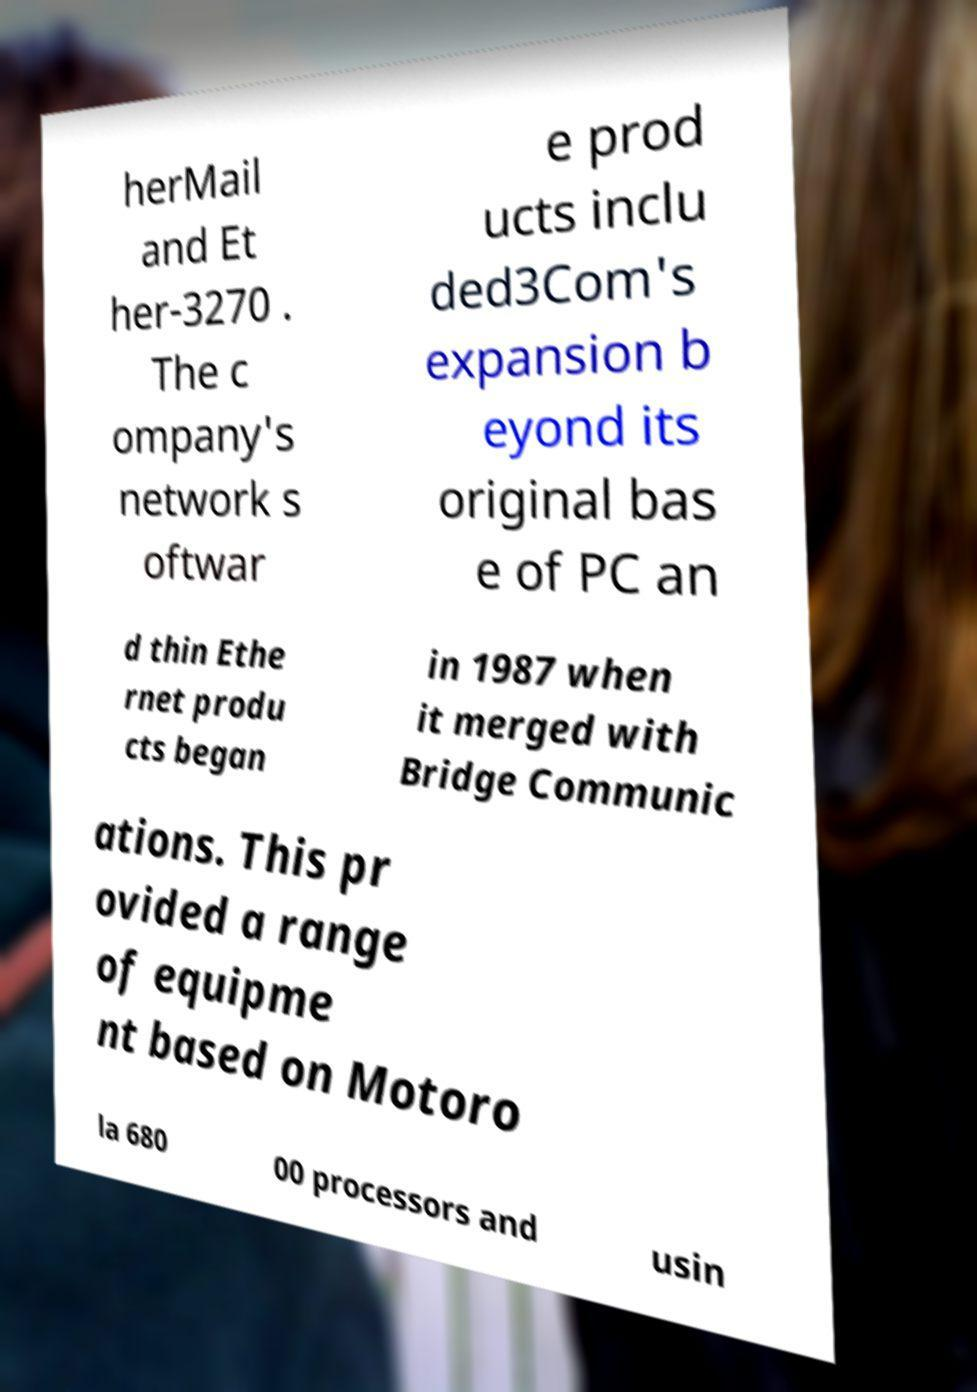What messages or text are displayed in this image? I need them in a readable, typed format. herMail and Et her-3270 . The c ompany's network s oftwar e prod ucts inclu ded3Com's expansion b eyond its original bas e of PC an d thin Ethe rnet produ cts began in 1987 when it merged with Bridge Communic ations. This pr ovided a range of equipme nt based on Motoro la 680 00 processors and usin 